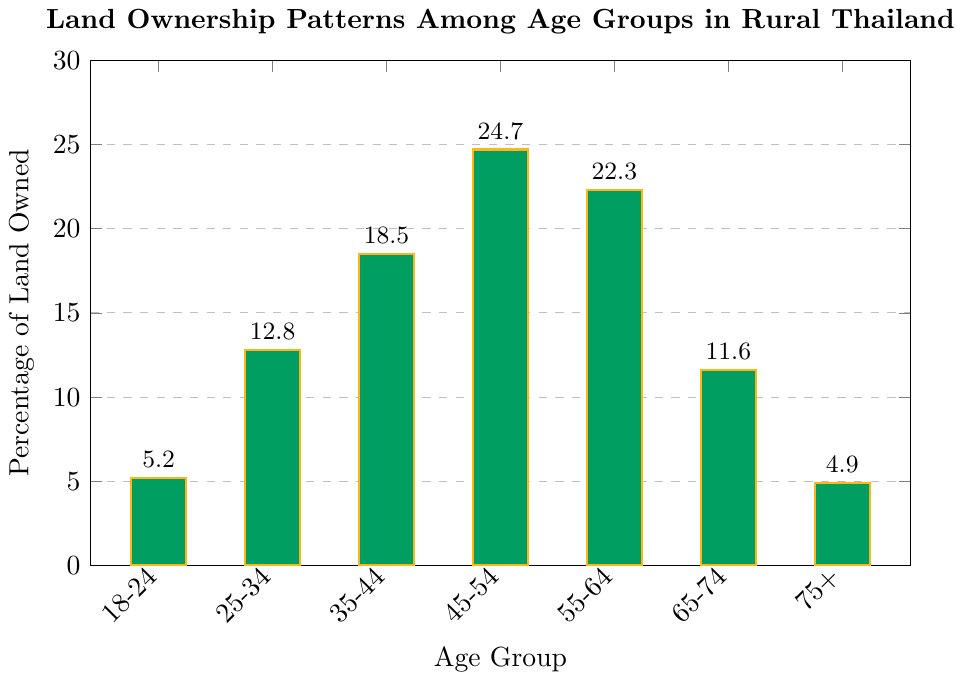Which age group owns the highest percentage of land? From the bar chart, the tallest bar represents the age group 45-54, which corresponds to the highest percentage of land ownership at 24.7%.
Answer: The age group 45-54 Which age group owns more land: 25-34 or 65-74? By observing the heights of the bars, the bar for the age group 25-34 is taller than that for 65-74, indicating that 25-34 owns more land (12.8% compared to 11.6%).
Answer: The age group 25-34 What is the combined percentage of land owned by the youngest and oldest age groups (18-24 and 75+)? Add the percentages of land owned by the 18-24 (5.2%) and 75+ (4.9%) age groups: 5.2 + 4.9 = 10.1%.
Answer: 10.1% Which age group owns less than 10% of the land? From the bar chart, only the age groups 18-24 (5.2%) and 75+ (4.9%) own less than 10% of the land.
Answer: Age groups 18-24 and 75+ What is the difference in land ownership between the age groups 35-44 and 45-54? Subtract the percentage of land owned by the 35-44 group (18.5%) from the 45-54 group (24.7%): 24.7 - 18.5 = 6.2%.
Answer: 6.2% What percentage of land is owned by the age group 35-44? The bar representing the age group 35-44 is labeled with the percentage 18.5%.
Answer: 18.5% Compare the land ownership of the age groups 45-54 and 55-64. Which group owns more, and by how much? By examining the bar chart, the age group 45-54 owns 24.7% while the age group 55-64 owns 22.3%. The difference is 24.7 - 22.3 = 2.4%.
Answer: The age group 45-54 owns 2.4% more What is the total percentage of land owned by age groups 45-54 and 55-64? Add the percentages of land owned by the age groups 45-54 (24.7%) and 55-64 (22.3%): 24.7 + 22.3 = 47.0%.
Answer: 47.0% Which age group shows the sharpest decrease in land ownership compared to the previous group? By examining the bars, the sharpest decrease occurs between the age groups 55-64 (22.3%) and 65-74 (11.6%); the difference is 22.3 - 11.6 = 10.7%.
Answer: The age group 65-74 How does the land ownership pattern change from the age group 35-44 to 45-54? The percentage of land owned increases from 18.5% for the age group 35-44 to 24.7% for the age group 45-54.
Answer: It increases 